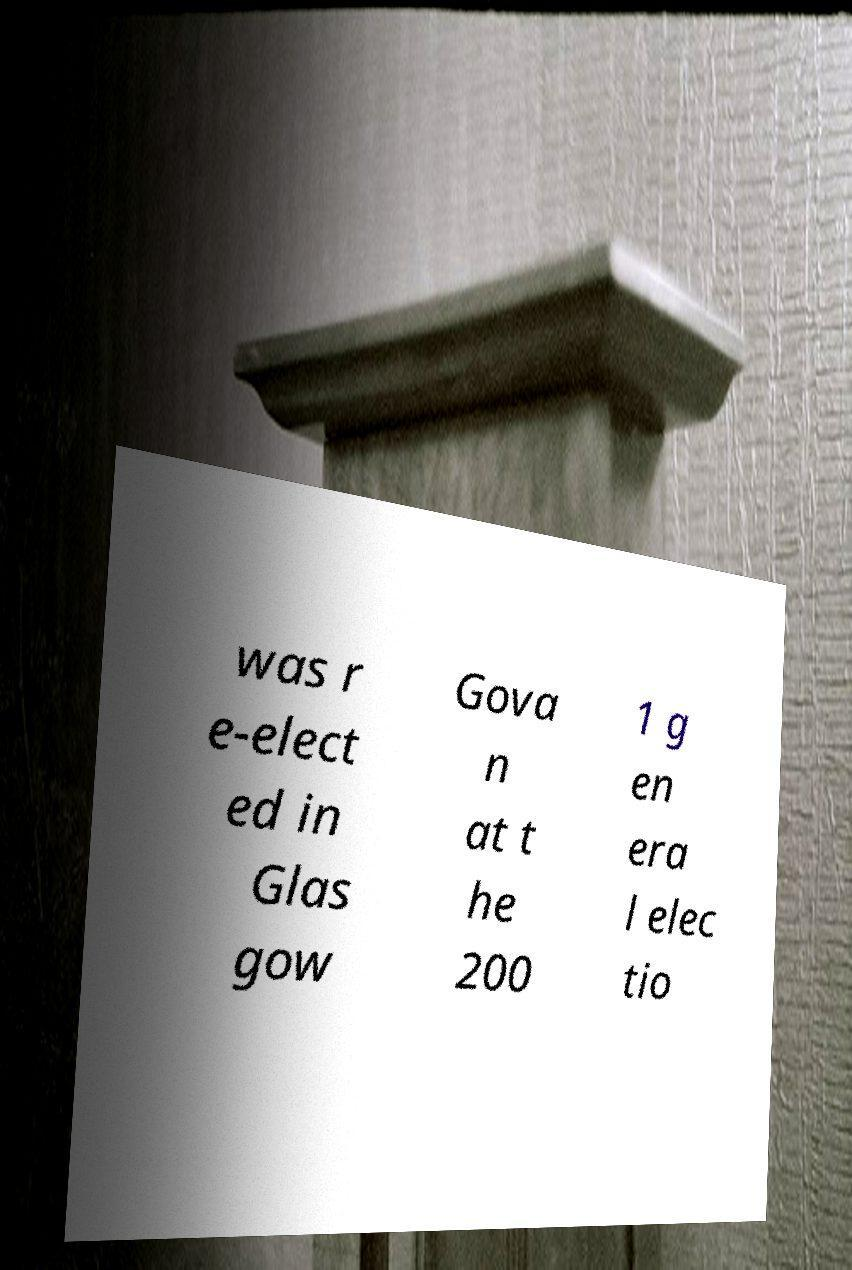Please read and relay the text visible in this image. What does it say? was r e-elect ed in Glas gow Gova n at t he 200 1 g en era l elec tio 